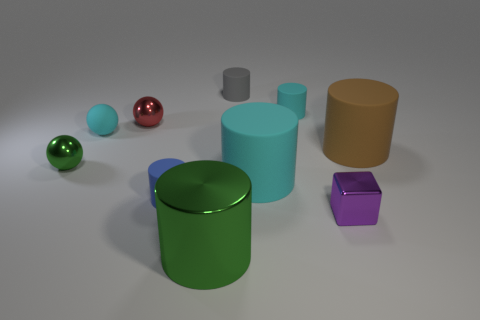What number of metal objects are big cylinders or cyan cylinders?
Keep it short and to the point. 1. Are there any small things?
Your answer should be very brief. Yes. Is the large green object the same shape as the brown object?
Offer a terse response. Yes. What number of big matte objects are left of the thing behind the cyan cylinder that is to the right of the large cyan object?
Keep it short and to the point. 0. There is a tiny thing that is both to the right of the small matte ball and left of the blue cylinder; what material is it?
Ensure brevity in your answer.  Metal. The metallic object that is in front of the small red object and behind the tiny cube is what color?
Keep it short and to the point. Green. Are there any other things that have the same color as the small block?
Give a very brief answer. No. What is the shape of the small metal object in front of the tiny thing left of the cyan object that is on the left side of the big green metal thing?
Ensure brevity in your answer.  Cube. What color is the rubber object that is the same shape as the red shiny object?
Provide a succinct answer. Cyan. The big rubber cylinder that is left of the metal object that is right of the large green thing is what color?
Ensure brevity in your answer.  Cyan. 